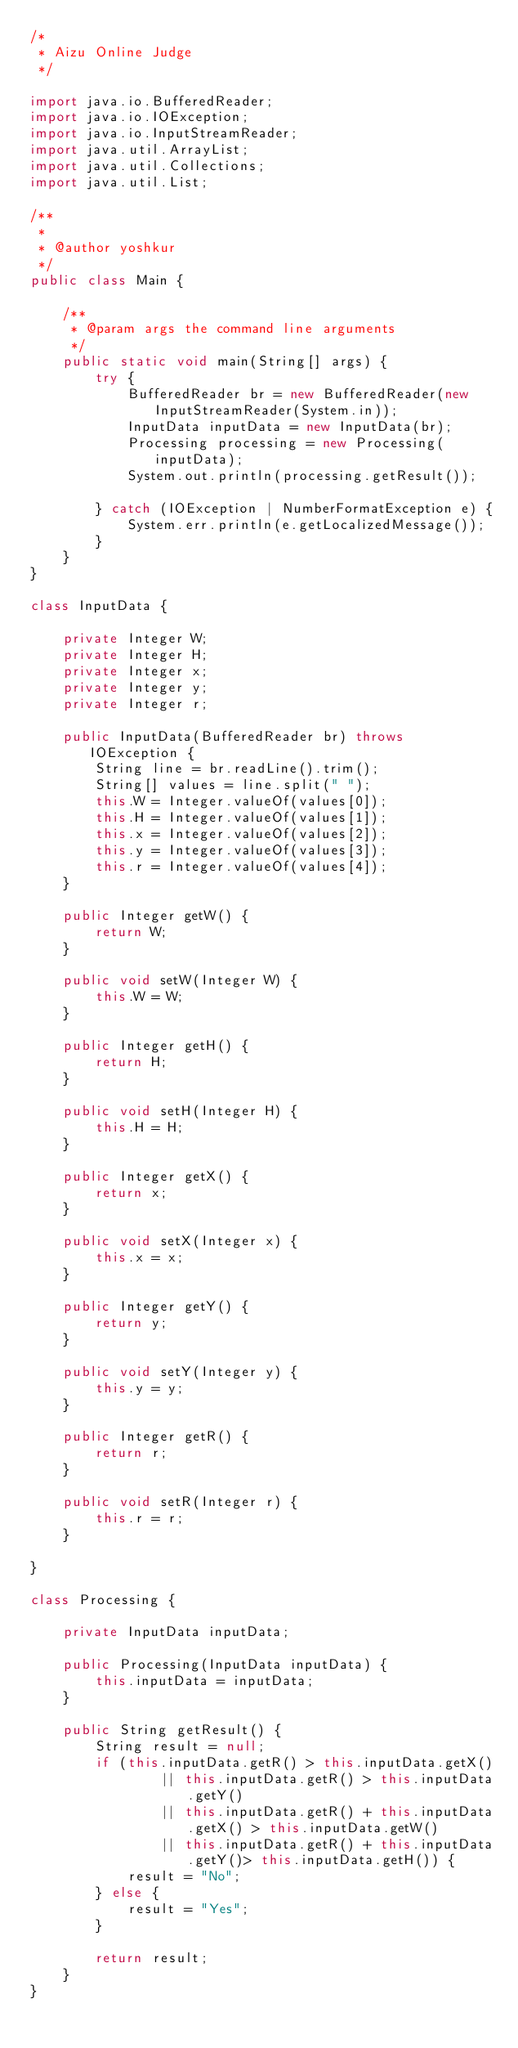Convert code to text. <code><loc_0><loc_0><loc_500><loc_500><_Java_>/*
 * Aizu Online Judge
 */

import java.io.BufferedReader;
import java.io.IOException;
import java.io.InputStreamReader;
import java.util.ArrayList;
import java.util.Collections;
import java.util.List;

/**
 *
 * @author yoshkur
 */
public class Main {

	/**
	 * @param args the command line arguments
	 */
	public static void main(String[] args) {
		try {
			BufferedReader br = new BufferedReader(new InputStreamReader(System.in));
			InputData inputData = new InputData(br);
			Processing processing = new Processing(inputData);
			System.out.println(processing.getResult());

		} catch (IOException | NumberFormatException e) {
			System.err.println(e.getLocalizedMessage());
		}
	}
}

class InputData {

	private Integer W;
	private Integer H;
	private Integer x;
	private Integer y;
	private Integer r;

	public InputData(BufferedReader br) throws IOException {
		String line = br.readLine().trim();
		String[] values = line.split(" ");
		this.W = Integer.valueOf(values[0]);
		this.H = Integer.valueOf(values[1]);
		this.x = Integer.valueOf(values[2]);
		this.y = Integer.valueOf(values[3]);
		this.r = Integer.valueOf(values[4]);
	}

	public Integer getW() {
		return W;
	}

	public void setW(Integer W) {
		this.W = W;
	}

	public Integer getH() {
		return H;
	}

	public void setH(Integer H) {
		this.H = H;
	}

	public Integer getX() {
		return x;
	}

	public void setX(Integer x) {
		this.x = x;
	}

	public Integer getY() {
		return y;
	}

	public void setY(Integer y) {
		this.y = y;
	}

	public Integer getR() {
		return r;
	}

	public void setR(Integer r) {
		this.r = r;
	}

}

class Processing {

	private InputData inputData;

	public Processing(InputData inputData) {
		this.inputData = inputData;
	}

	public String getResult() {
		String result = null;
		if (this.inputData.getR() > this.inputData.getX() 
				|| this.inputData.getR() > this.inputData.getY() 
				|| this.inputData.getR() + this.inputData.getX() > this.inputData.getW() 
				|| this.inputData.getR() + this.inputData.getY()> this.inputData.getH()) {
			result = "No";
		} else {
			result = "Yes";
		}
		
		return result;
	}
}</code> 